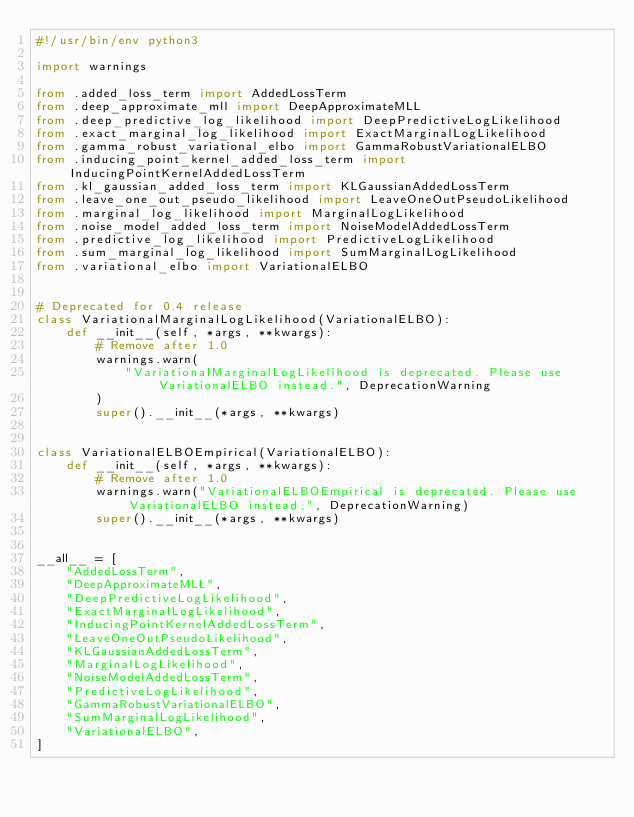<code> <loc_0><loc_0><loc_500><loc_500><_Python_>#!/usr/bin/env python3

import warnings

from .added_loss_term import AddedLossTerm
from .deep_approximate_mll import DeepApproximateMLL
from .deep_predictive_log_likelihood import DeepPredictiveLogLikelihood
from .exact_marginal_log_likelihood import ExactMarginalLogLikelihood
from .gamma_robust_variational_elbo import GammaRobustVariationalELBO
from .inducing_point_kernel_added_loss_term import InducingPointKernelAddedLossTerm
from .kl_gaussian_added_loss_term import KLGaussianAddedLossTerm
from .leave_one_out_pseudo_likelihood import LeaveOneOutPseudoLikelihood
from .marginal_log_likelihood import MarginalLogLikelihood
from .noise_model_added_loss_term import NoiseModelAddedLossTerm
from .predictive_log_likelihood import PredictiveLogLikelihood
from .sum_marginal_log_likelihood import SumMarginalLogLikelihood
from .variational_elbo import VariationalELBO


# Deprecated for 0.4 release
class VariationalMarginalLogLikelihood(VariationalELBO):
    def __init__(self, *args, **kwargs):
        # Remove after 1.0
        warnings.warn(
            "VariationalMarginalLogLikelihood is deprecated. Please use VariationalELBO instead.", DeprecationWarning
        )
        super().__init__(*args, **kwargs)


class VariationalELBOEmpirical(VariationalELBO):
    def __init__(self, *args, **kwargs):
        # Remove after 1.0
        warnings.warn("VariationalELBOEmpirical is deprecated. Please use VariationalELBO instead.", DeprecationWarning)
        super().__init__(*args, **kwargs)


__all__ = [
    "AddedLossTerm",
    "DeepApproximateMLL",
    "DeepPredictiveLogLikelihood",
    "ExactMarginalLogLikelihood",
    "InducingPointKernelAddedLossTerm",
    "LeaveOneOutPseudoLikelihood",
    "KLGaussianAddedLossTerm",
    "MarginalLogLikelihood",
    "NoiseModelAddedLossTerm",
    "PredictiveLogLikelihood",
    "GammaRobustVariationalELBO",
    "SumMarginalLogLikelihood",
    "VariationalELBO",
]
</code> 